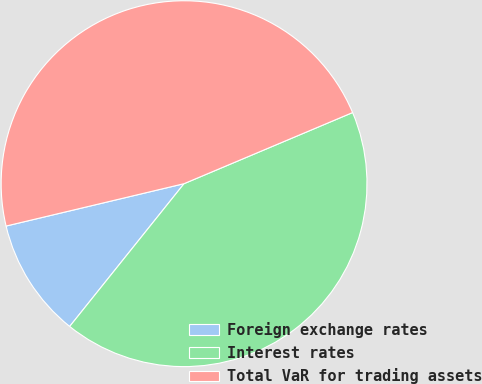<chart> <loc_0><loc_0><loc_500><loc_500><pie_chart><fcel>Foreign exchange rates<fcel>Interest rates<fcel>Total VaR for trading assets<nl><fcel>10.53%<fcel>42.11%<fcel>47.37%<nl></chart> 